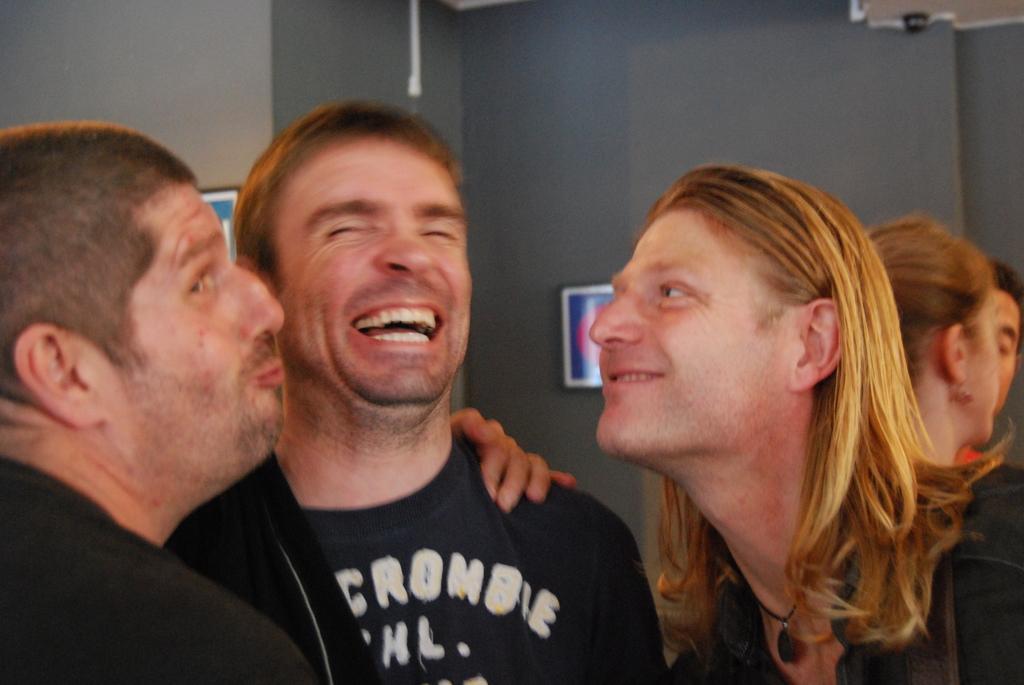Please provide a concise description of this image. In this image, we can see some people standing, in the background, we can see a wall and there are two photos on the wall. 